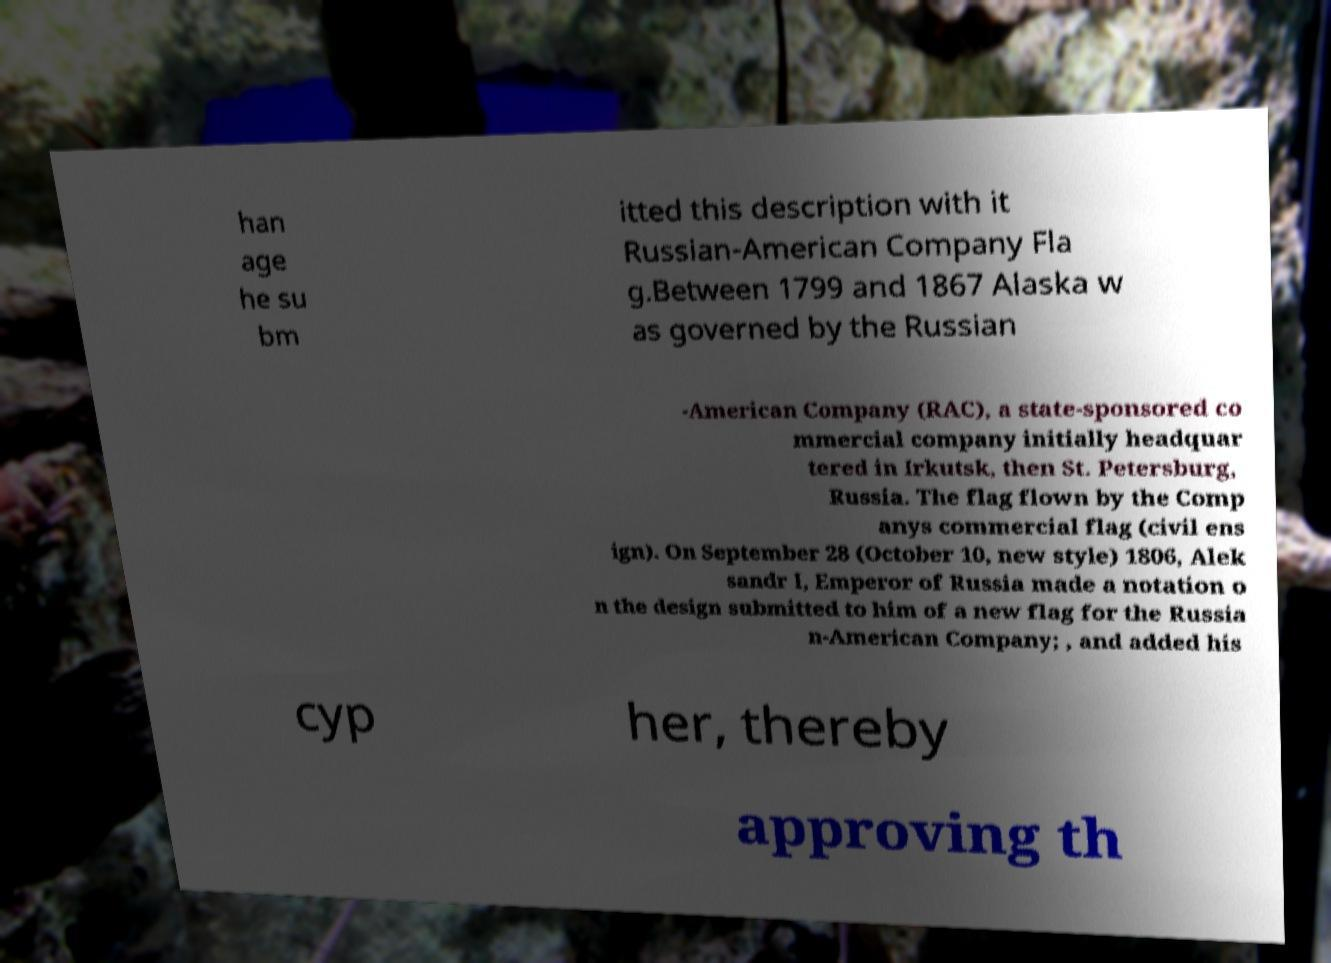Can you read and provide the text displayed in the image?This photo seems to have some interesting text. Can you extract and type it out for me? han age he su bm itted this description with it Russian-American Company Fla g.Between 1799 and 1867 Alaska w as governed by the Russian -American Company (RAC), a state-sponsored co mmercial company initially headquar tered in Irkutsk, then St. Petersburg, Russia. The flag flown by the Comp anys commercial flag (civil ens ign). On September 28 (October 10, new style) 1806, Alek sandr I, Emperor of Russia made a notation o n the design submitted to him of a new flag for the Russia n-American Company; , and added his cyp her, thereby approving th 